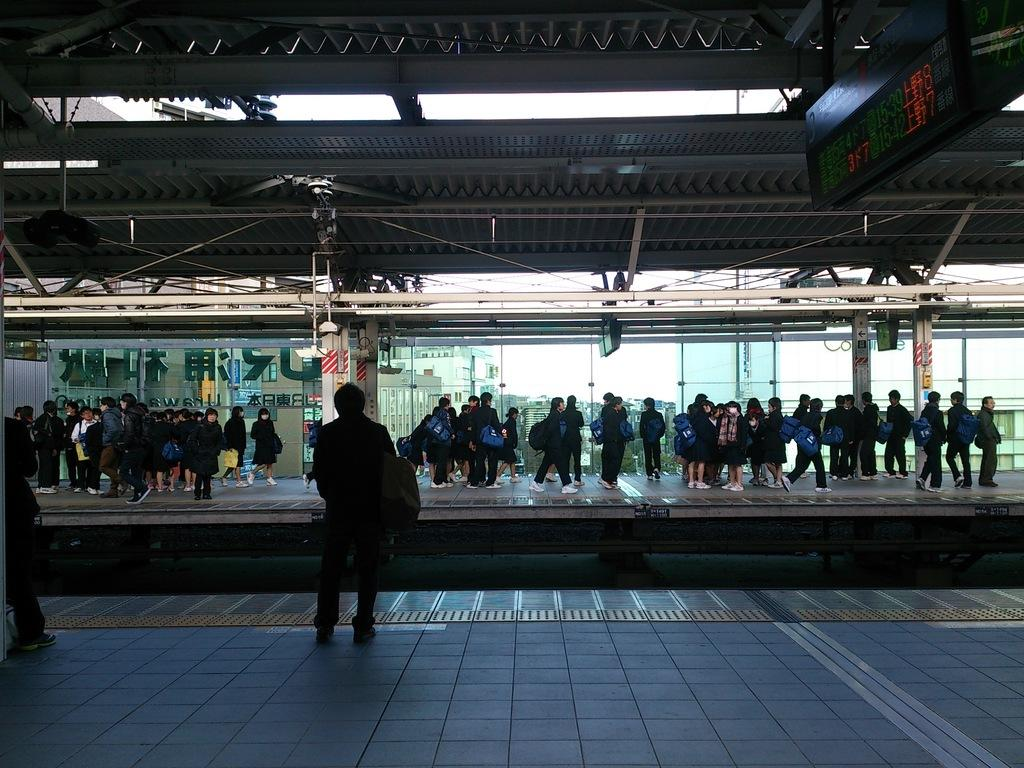Who or what can be seen in the image? There are people in the image. What objects are visible with the people? There are bags in the image. What can be seen in the distance behind the people? There is a building in the background of the image. Where is the written text board located in the image? The written text board is on the right side of the image. What type of window operation is being performed by the people in the image? There is no window or window operation present in the image; it features people with bags and a building in the background. 